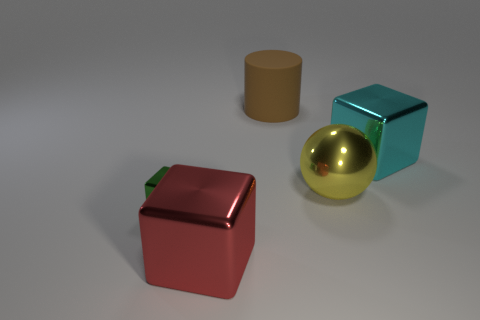There is a large thing to the right of the yellow ball; does it have the same shape as the yellow metallic thing?
Offer a terse response. No. What number of other objects are there of the same color as the matte cylinder?
Offer a terse response. 0. There is a large brown rubber object; are there any green metal objects in front of it?
Offer a terse response. Yes. How many objects are either rubber things or large blocks on the left side of the big rubber object?
Provide a short and direct response. 2. There is a big cyan thing that is right of the large yellow metallic sphere; is there a object behind it?
Offer a very short reply. Yes. The big object behind the metal cube right of the large shiny object in front of the tiny green block is what shape?
Offer a very short reply. Cylinder. There is a thing that is behind the large yellow object and to the left of the big cyan cube; what is its color?
Make the answer very short. Brown. What shape is the large thing that is left of the large brown matte object?
Your answer should be very brief. Cube. What is the shape of the yellow thing that is made of the same material as the green block?
Make the answer very short. Sphere. How many matte things are tiny blocks or tiny red spheres?
Ensure brevity in your answer.  0. 